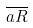Convert formula to latex. <formula><loc_0><loc_0><loc_500><loc_500>\overline { a R }</formula> 